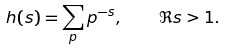<formula> <loc_0><loc_0><loc_500><loc_500>h ( s ) = \sum _ { p } p ^ { - s } , \quad \Re { s } > 1 .</formula> 